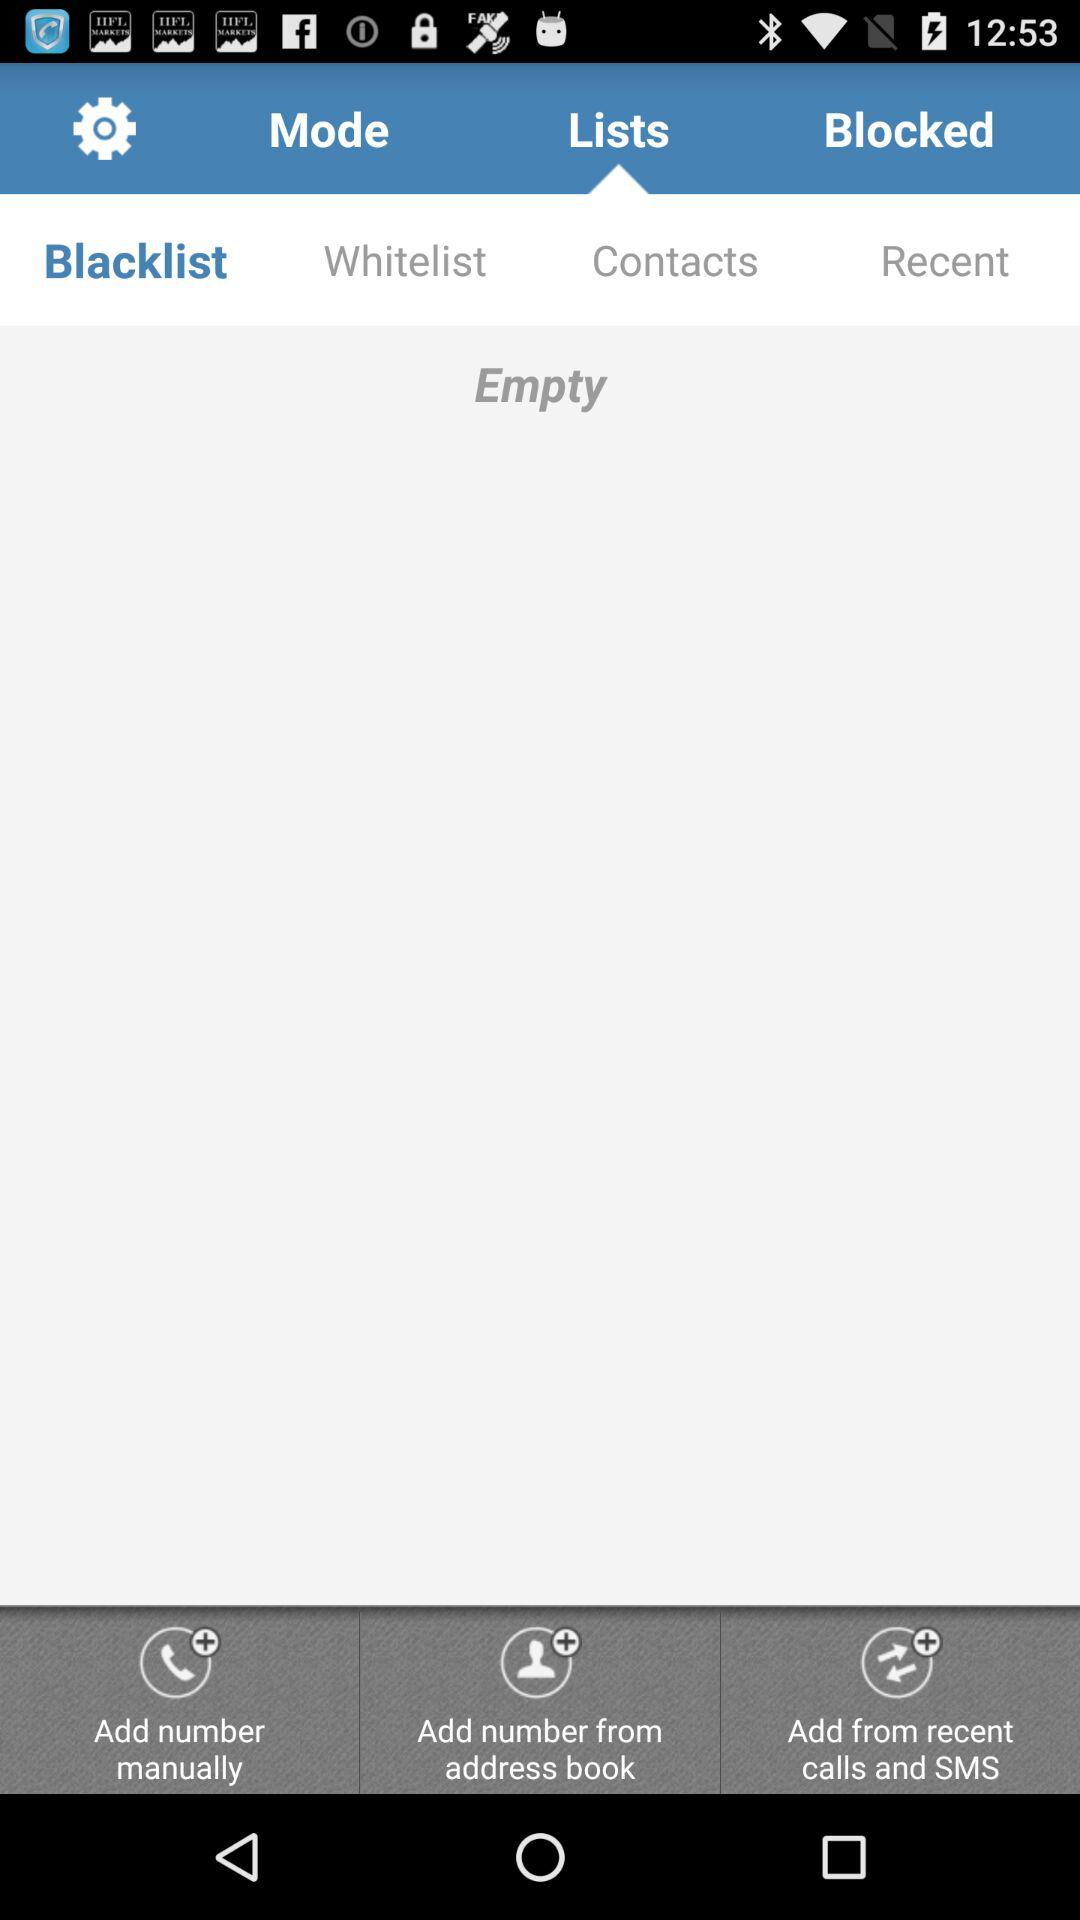Which tab is selected? The selected tab is "Lists". 